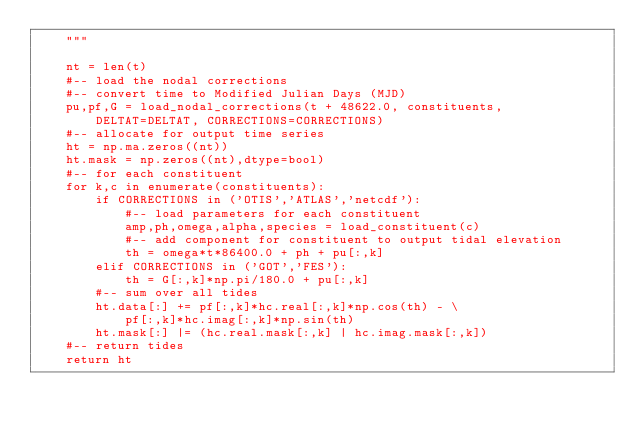<code> <loc_0><loc_0><loc_500><loc_500><_Python_>    """

    nt = len(t)
    #-- load the nodal corrections
    #-- convert time to Modified Julian Days (MJD)
    pu,pf,G = load_nodal_corrections(t + 48622.0, constituents,
        DELTAT=DELTAT, CORRECTIONS=CORRECTIONS)
    #-- allocate for output time series
    ht = np.ma.zeros((nt))
    ht.mask = np.zeros((nt),dtype=bool)
    #-- for each constituent
    for k,c in enumerate(constituents):
        if CORRECTIONS in ('OTIS','ATLAS','netcdf'):
            #-- load parameters for each constituent
            amp,ph,omega,alpha,species = load_constituent(c)
            #-- add component for constituent to output tidal elevation
            th = omega*t*86400.0 + ph + pu[:,k]
        elif CORRECTIONS in ('GOT','FES'):
            th = G[:,k]*np.pi/180.0 + pu[:,k]
        #-- sum over all tides
        ht.data[:] += pf[:,k]*hc.real[:,k]*np.cos(th) - \
            pf[:,k]*hc.imag[:,k]*np.sin(th)
        ht.mask[:] |= (hc.real.mask[:,k] | hc.imag.mask[:,k])
    #-- return tides
    return ht
</code> 